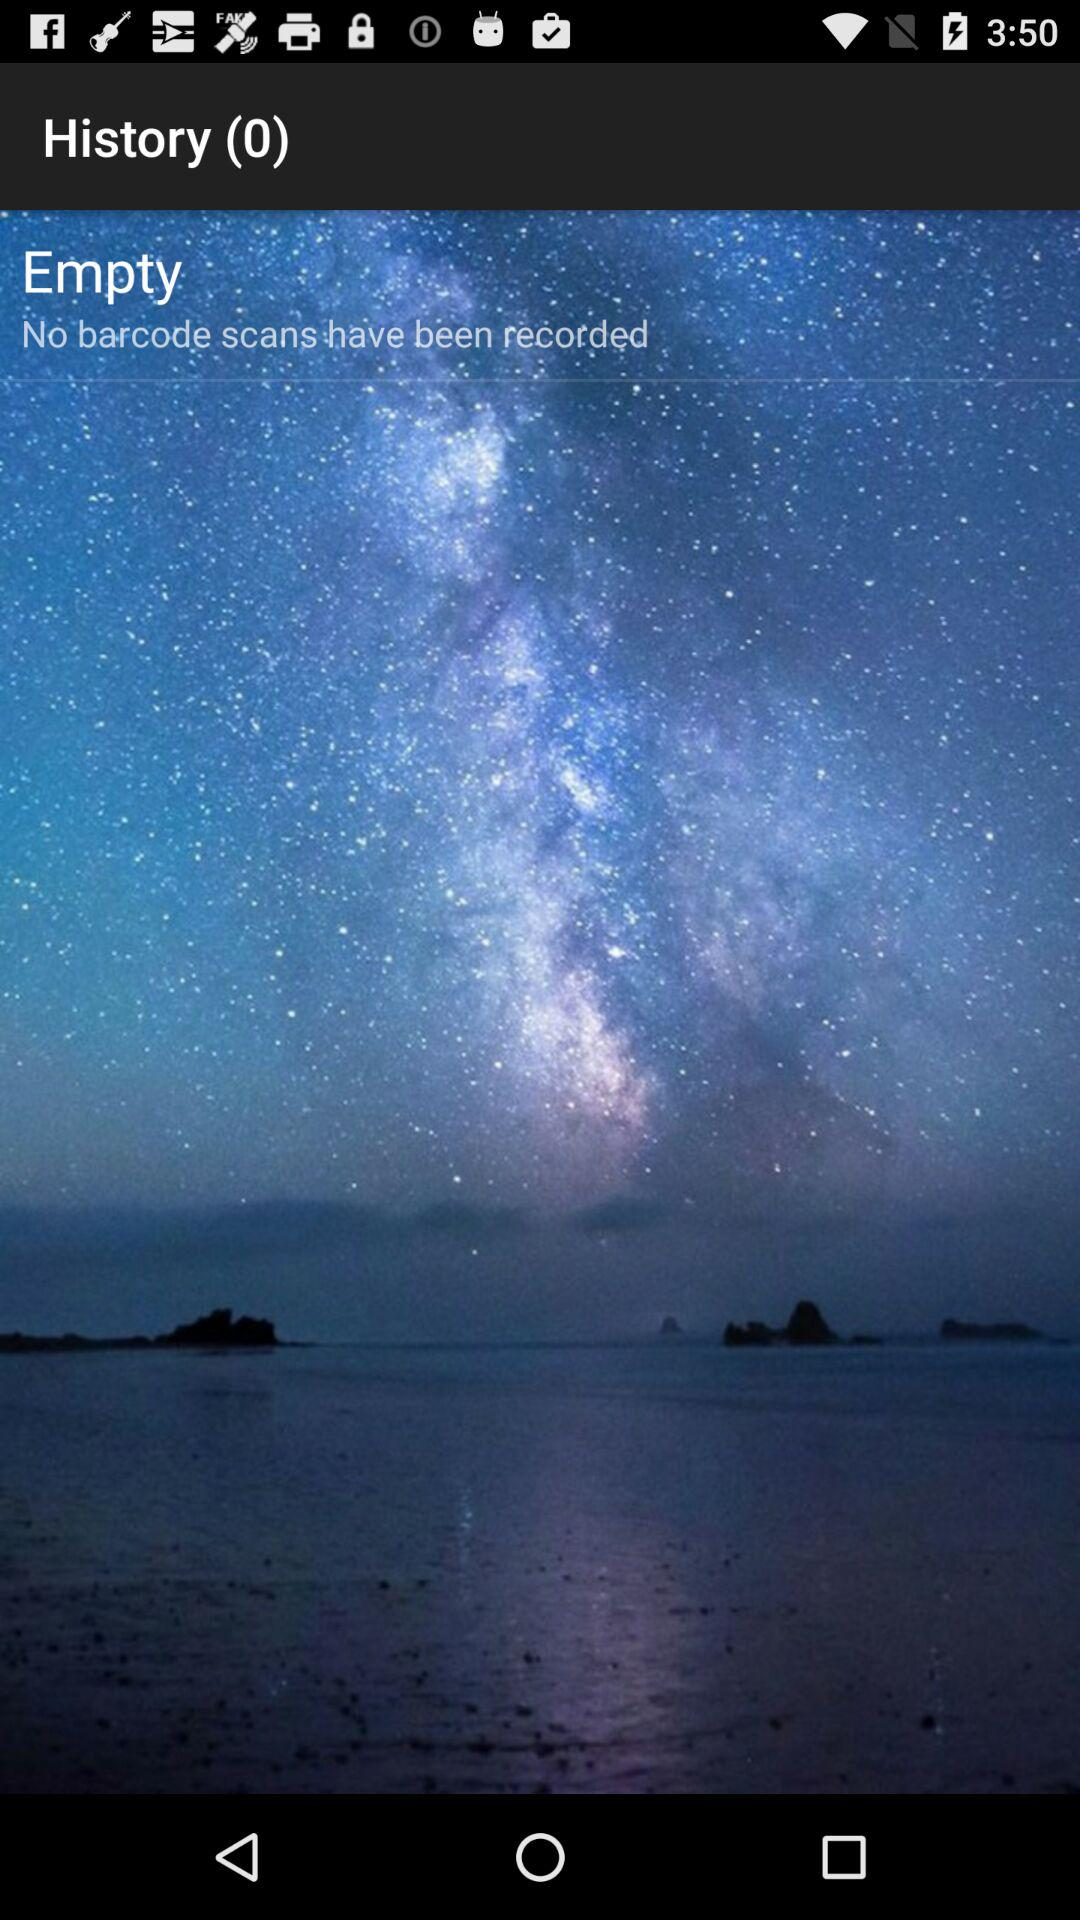What is the name of the application?
When the provided information is insufficient, respond with <no answer>. <no answer> 